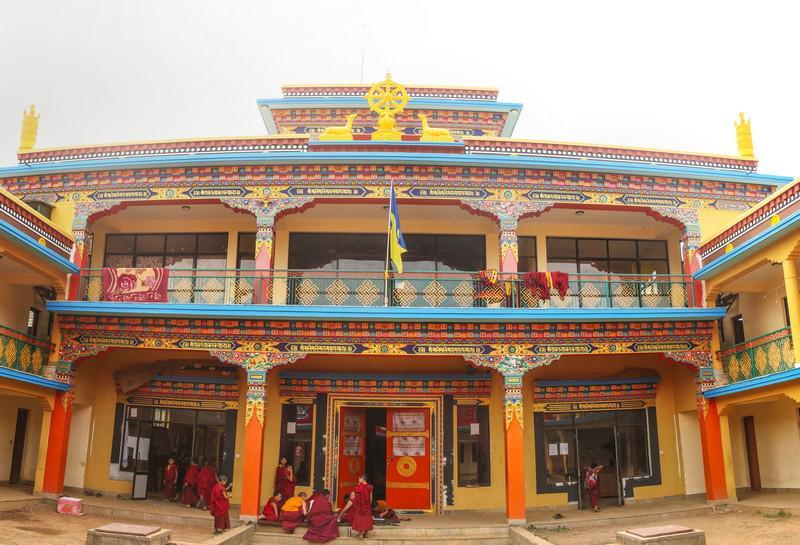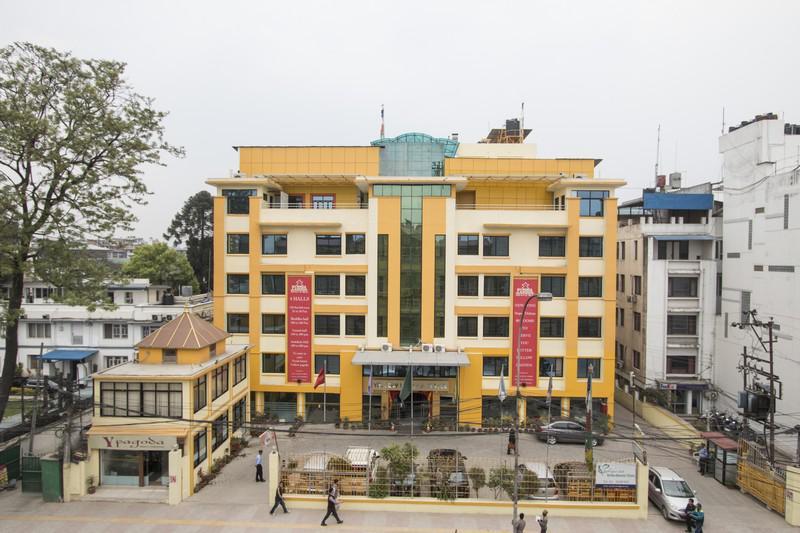The first image is the image on the left, the second image is the image on the right. Analyze the images presented: Is the assertion "The left and right image contains the same number of floors in the building." valid? Answer yes or no. No. 